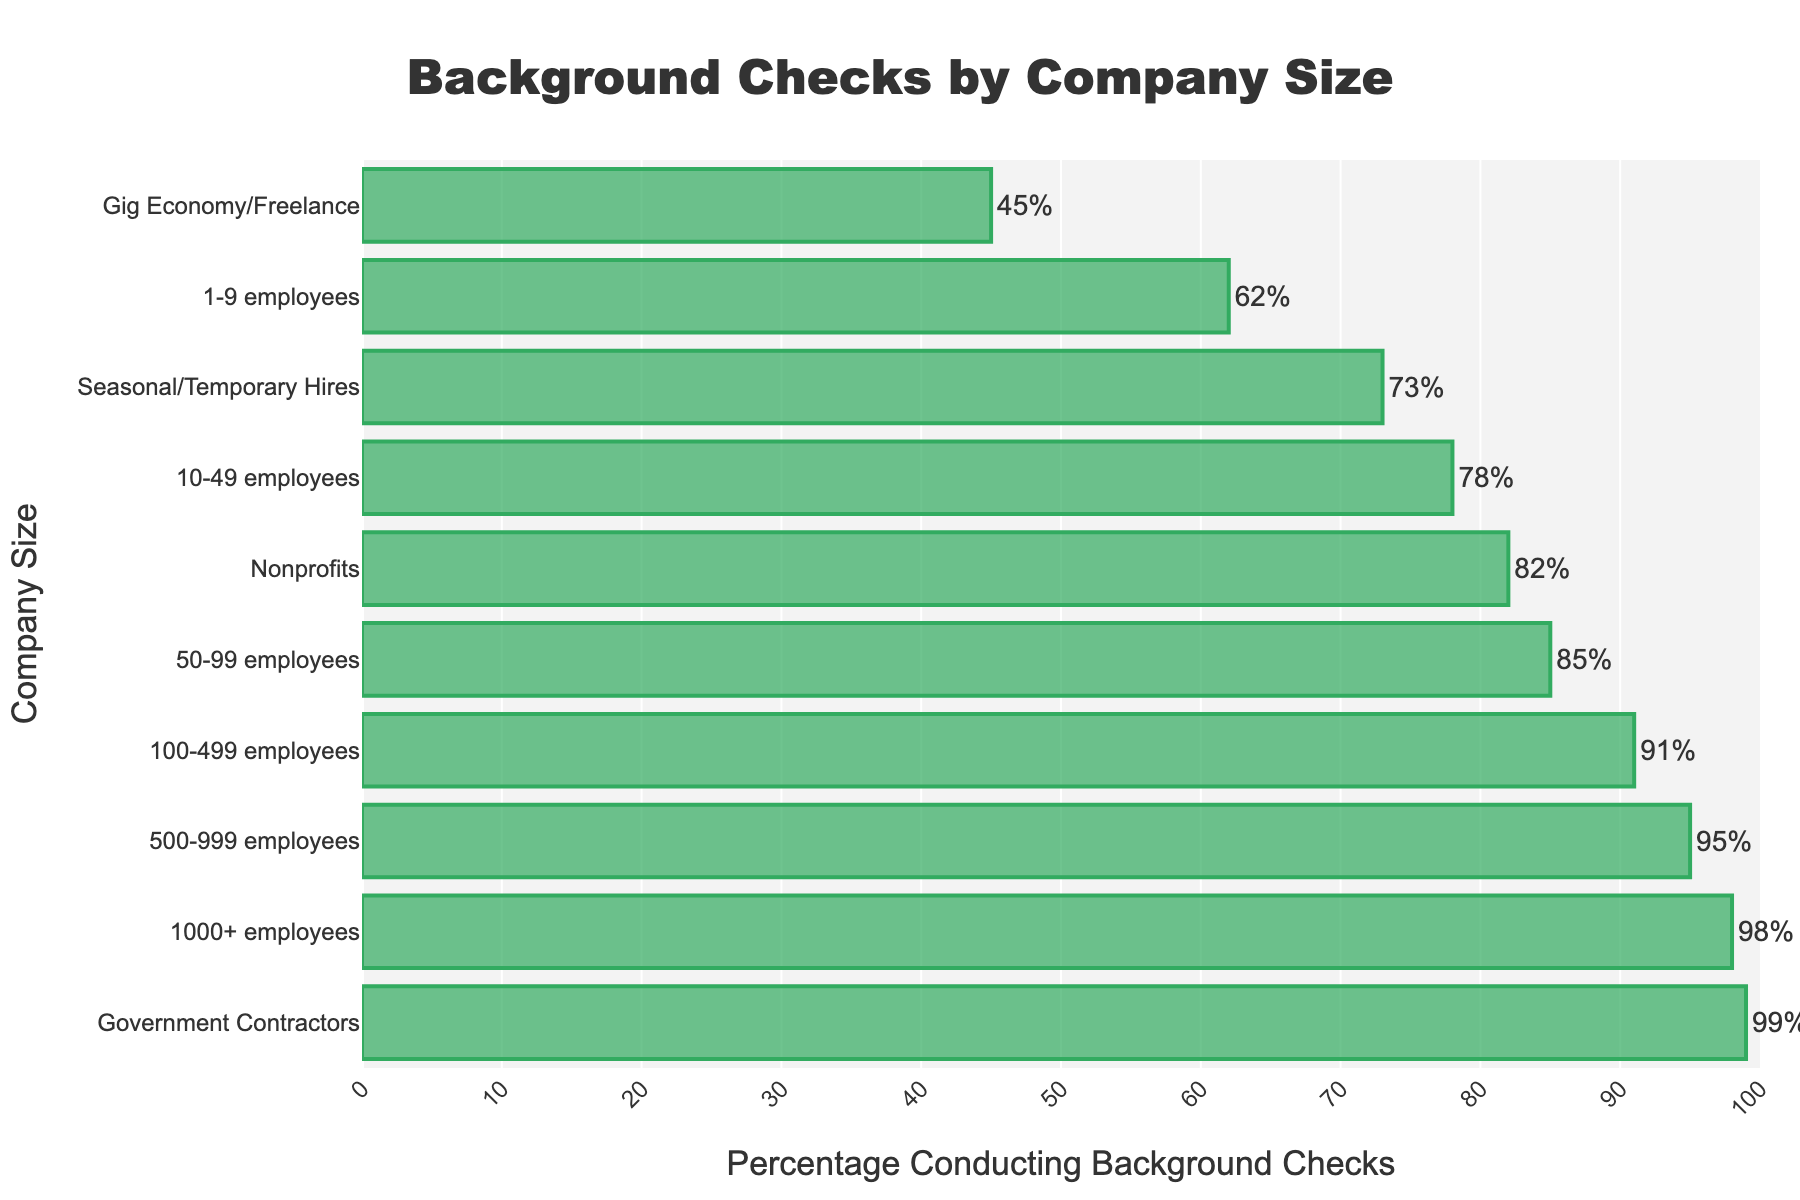What percentage of companies with 1-9 employees conduct background checks on potential hires? Look for the bar corresponding to "1-9 employees" and read the percentage value.
Answer: 62% Which company size has the highest percentage of conducting background checks? Identify the bar with the greatest length and read the company size label next to it.
Answer: Government Contractors Compare the percentage of background checks between companies with 100-499 employees and 50-99 employees. Read the percentages for each company size from the bars and compare them.
Answer: 100-499 employees: 91%, 50-99 employees: 85% What's the difference in the percentage of background checks between companies with 500-999 employees and gig economy/freelance businesses? Subtract the percentage of gig economy/freelance from the percentage of 500-999 employees.
Answer: 95% - 45% = 50% What is the median percentage value of all the provided company sizes conducting background checks? List all the percentages in ascending order and find the middle value(s). If there is an even number of percentages, calculate the average of the two middle values.
Answer: Median value: 85% How does the percentage of nonprofits conducting background checks compare to seasonal/temporary hires? Read the percentages for both "Nonprofits" and "Seasonal/Temporary Hires" from the bars and compare them.
Answer: Nonprofits: 82%, Seasonal/Temporary Hires: 73% What percentage of gig economy/freelance businesses conduct background checks? Locate the bar for "Gig Economy/Freelance" and read the corresponding percentage.
Answer: 45% Which company size has the lowest percentage of conducting background checks, and what is that percentage? Identify the shortest bar, read the company size and its corresponding percentage.
Answer: Gig Economy/Freelance, 45% What is the average percentage of background checks for companies with 1-9, 10-49, and 50-99 employees? Add the percentages of the three company sizes and divide by 3.
Answer: (62% + 78% + 85%) / 3 = 75% Is the percentage of background checks higher for companies with 1000+ employees or government contractors? Compare the percentages for "1000+ employees" and "Government Contractors".
Answer: Government Contractors: 99%, 1000+ employees: 98% 